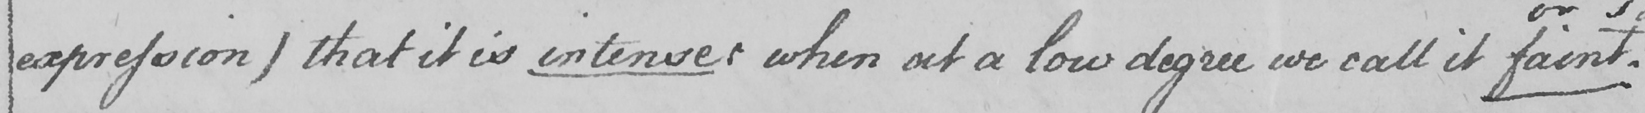Transcribe the text shown in this historical manuscript line. expression )  that it is intenser when at a low degree we call it faint  . 